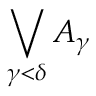Convert formula to latex. <formula><loc_0><loc_0><loc_500><loc_500>\bigvee _ { \gamma < \delta } { A _ { \gamma } }</formula> 